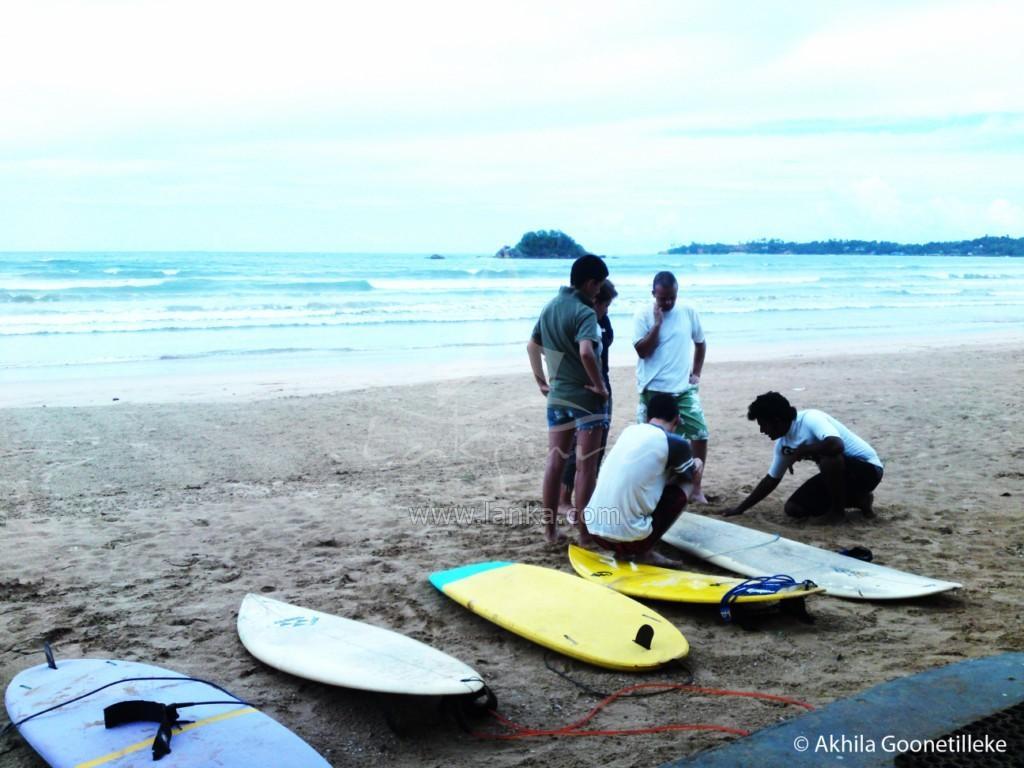How would you summarize this image in a sentence or two? In the image we can see there are people who are standing and sitting on the ground and there are surfboards on the ground and behind there is ocean. 